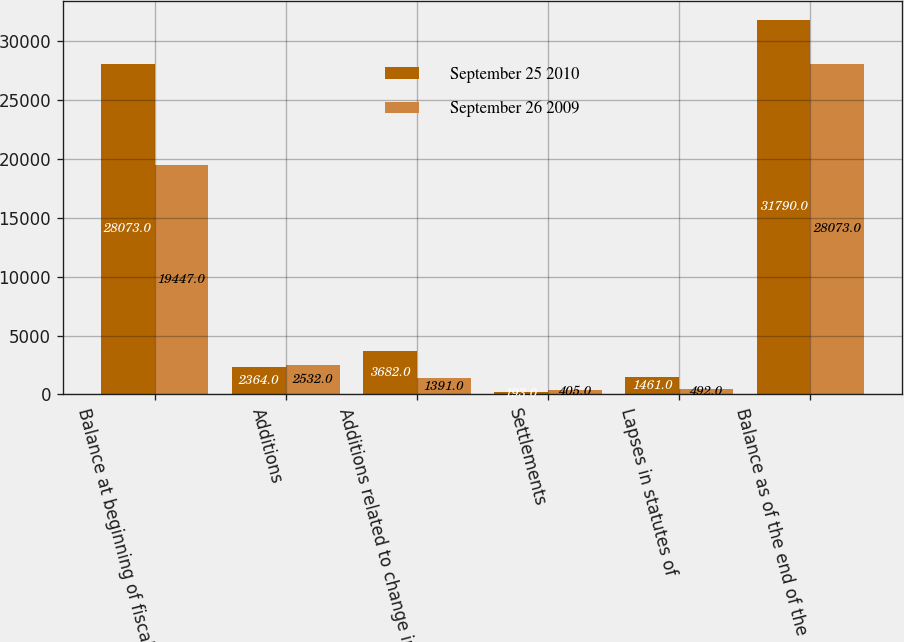Convert chart. <chart><loc_0><loc_0><loc_500><loc_500><stacked_bar_chart><ecel><fcel>Balance at beginning of fiscal<fcel>Additions<fcel>Additions related to change in<fcel>Settlements<fcel>Lapses in statutes of<fcel>Balance as of the end of the<nl><fcel>September 25 2010<fcel>28073<fcel>2364<fcel>3682<fcel>193<fcel>1461<fcel>31790<nl><fcel>September 26 2009<fcel>19447<fcel>2532<fcel>1391<fcel>405<fcel>492<fcel>28073<nl></chart> 